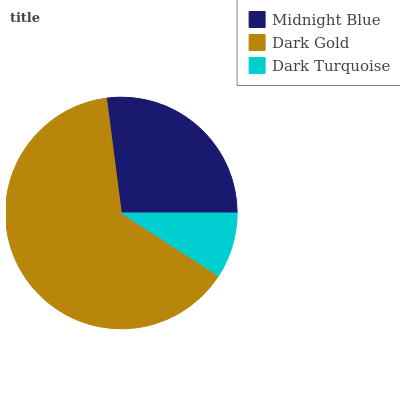Is Dark Turquoise the minimum?
Answer yes or no. Yes. Is Dark Gold the maximum?
Answer yes or no. Yes. Is Dark Gold the minimum?
Answer yes or no. No. Is Dark Turquoise the maximum?
Answer yes or no. No. Is Dark Gold greater than Dark Turquoise?
Answer yes or no. Yes. Is Dark Turquoise less than Dark Gold?
Answer yes or no. Yes. Is Dark Turquoise greater than Dark Gold?
Answer yes or no. No. Is Dark Gold less than Dark Turquoise?
Answer yes or no. No. Is Midnight Blue the high median?
Answer yes or no. Yes. Is Midnight Blue the low median?
Answer yes or no. Yes. Is Dark Turquoise the high median?
Answer yes or no. No. Is Dark Gold the low median?
Answer yes or no. No. 